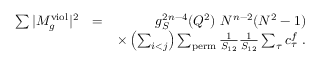Convert formula to latex. <formula><loc_0><loc_0><loc_500><loc_500>\begin{array} { r l r } { \sum | M _ { g } ^ { v i o l } | ^ { 2 } } & { = } & { g _ { S } ^ { 2 n - 4 } ( Q ^ { 2 } ) N ^ { n - 2 } ( N ^ { 2 } - 1 ) } \\ & { \times \left ( \sum _ { i < j } \right ) \sum _ { p e r m } \frac { 1 } { S _ { 1 2 } } \frac { 1 } { S _ { 1 2 } } \sum _ { \tau } c _ { \tau } ^ { f } . } \end{array}</formula> 